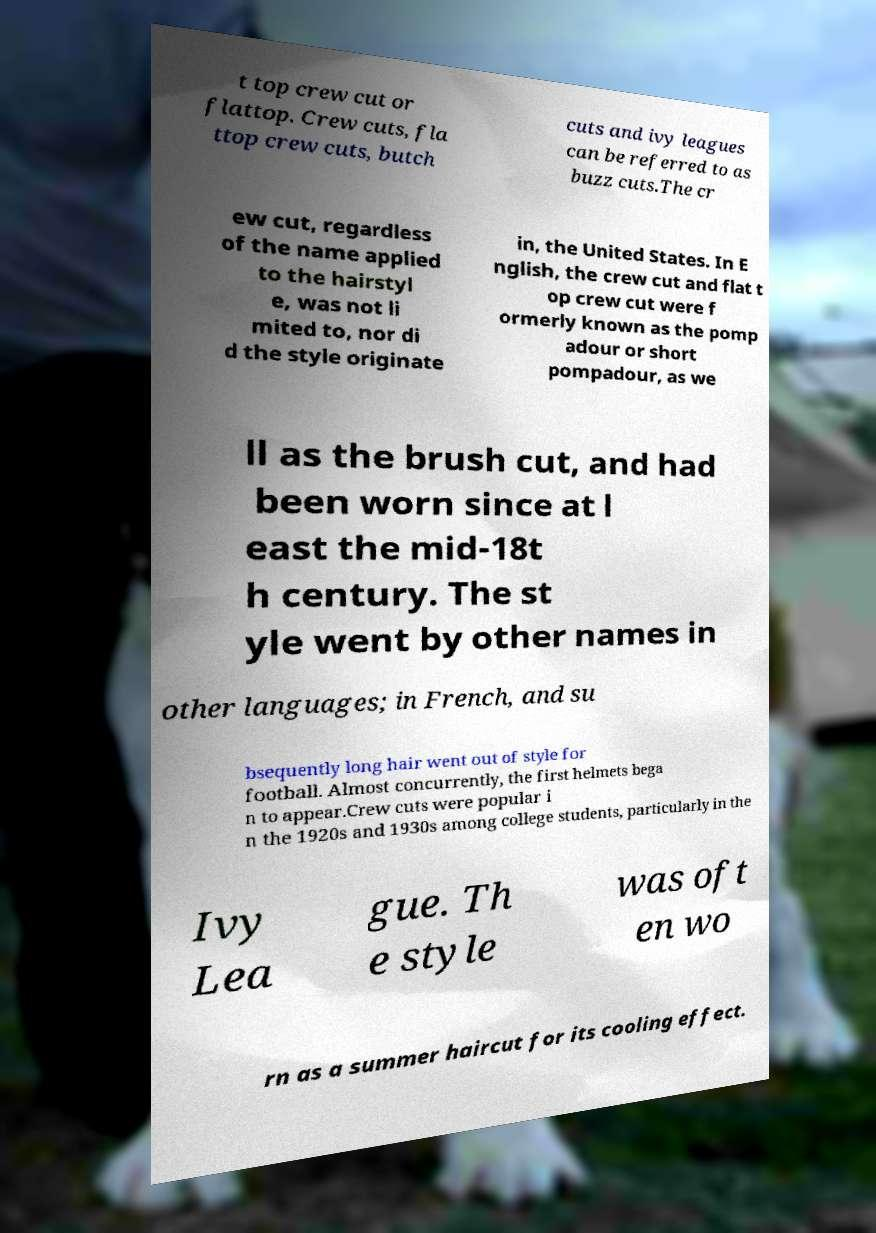Can you read and provide the text displayed in the image?This photo seems to have some interesting text. Can you extract and type it out for me? t top crew cut or flattop. Crew cuts, fla ttop crew cuts, butch cuts and ivy leagues can be referred to as buzz cuts.The cr ew cut, regardless of the name applied to the hairstyl e, was not li mited to, nor di d the style originate in, the United States. In E nglish, the crew cut and flat t op crew cut were f ormerly known as the pomp adour or short pompadour, as we ll as the brush cut, and had been worn since at l east the mid-18t h century. The st yle went by other names in other languages; in French, and su bsequently long hair went out of style for football. Almost concurrently, the first helmets bega n to appear.Crew cuts were popular i n the 1920s and 1930s among college students, particularly in the Ivy Lea gue. Th e style was oft en wo rn as a summer haircut for its cooling effect. 